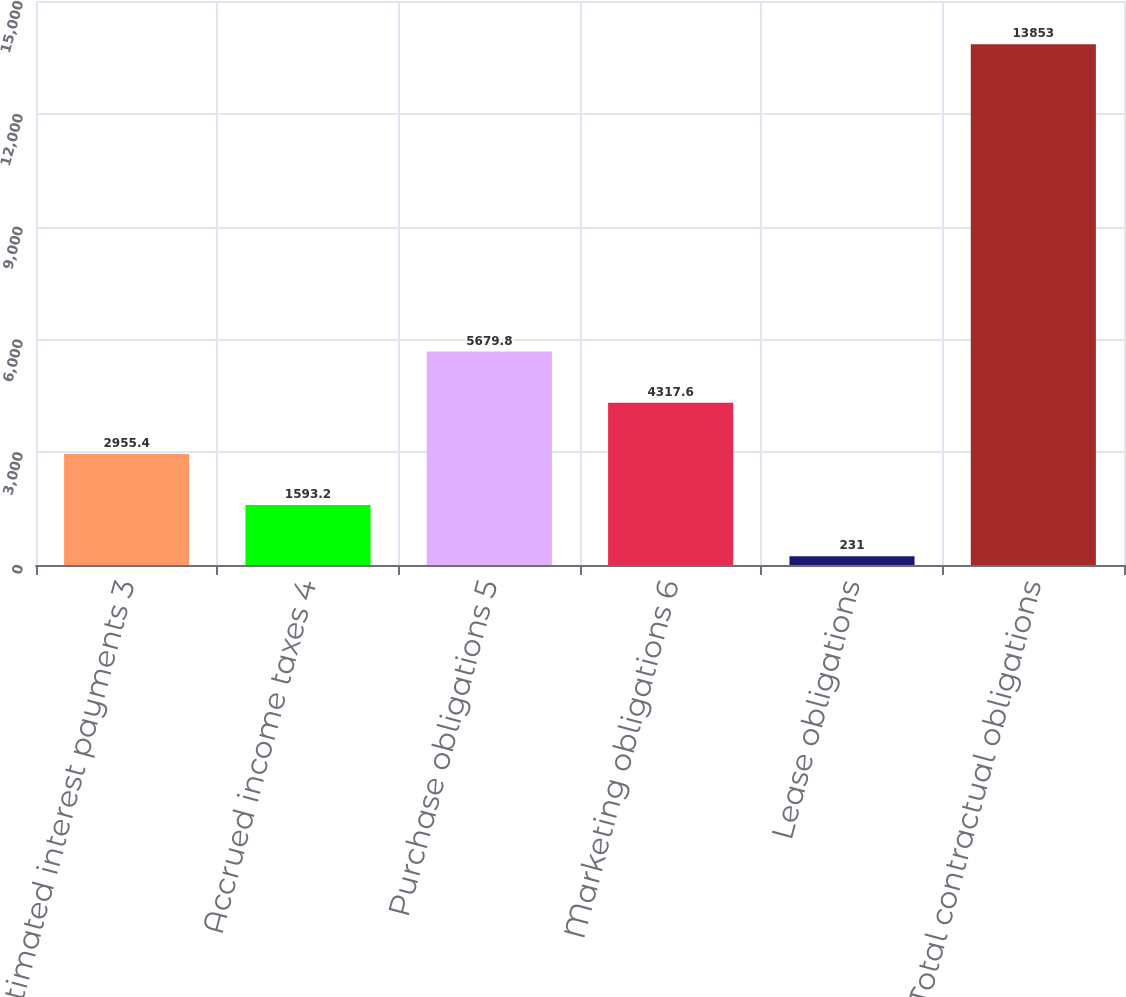Convert chart to OTSL. <chart><loc_0><loc_0><loc_500><loc_500><bar_chart><fcel>Estimated interest payments 3<fcel>Accrued income taxes 4<fcel>Purchase obligations 5<fcel>Marketing obligations 6<fcel>Lease obligations<fcel>Total contractual obligations<nl><fcel>2955.4<fcel>1593.2<fcel>5679.8<fcel>4317.6<fcel>231<fcel>13853<nl></chart> 